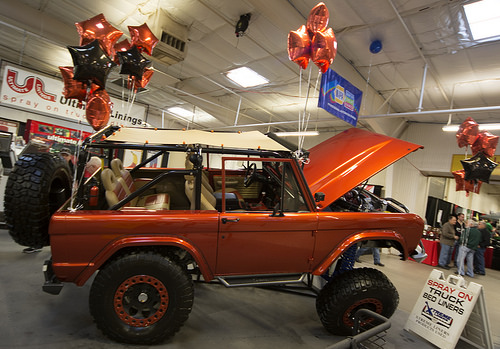<image>
Can you confirm if the baloon is on the jeep? No. The baloon is not positioned on the jeep. They may be near each other, but the baloon is not supported by or resting on top of the jeep. 